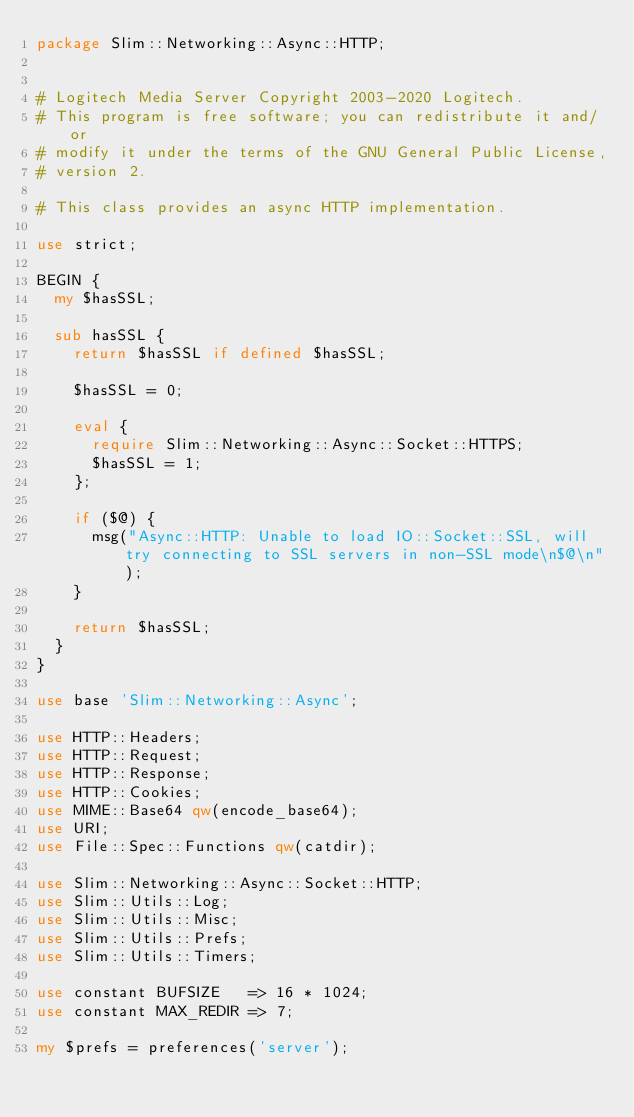<code> <loc_0><loc_0><loc_500><loc_500><_Perl_>package Slim::Networking::Async::HTTP;


# Logitech Media Server Copyright 2003-2020 Logitech.
# This program is free software; you can redistribute it and/or
# modify it under the terms of the GNU General Public License,
# version 2.

# This class provides an async HTTP implementation.

use strict;

BEGIN {
	my $hasSSL;

	sub hasSSL {
		return $hasSSL if defined $hasSSL;

		$hasSSL = 0;

		eval {
			require Slim::Networking::Async::Socket::HTTPS;
			$hasSSL = 1;
		};

		if ($@) {
			msg("Async::HTTP: Unable to load IO::Socket::SSL, will try connecting to SSL servers in non-SSL mode\n$@\n");
		}

		return $hasSSL;
	}
}

use base 'Slim::Networking::Async';

use HTTP::Headers;
use HTTP::Request;
use HTTP::Response;
use HTTP::Cookies;
use MIME::Base64 qw(encode_base64);
use URI;
use File::Spec::Functions qw(catdir);

use Slim::Networking::Async::Socket::HTTP;
use Slim::Utils::Log;
use Slim::Utils::Misc;
use Slim::Utils::Prefs;
use Slim::Utils::Timers;

use constant BUFSIZE   => 16 * 1024;
use constant MAX_REDIR => 7;

my $prefs = preferences('server');
</code> 